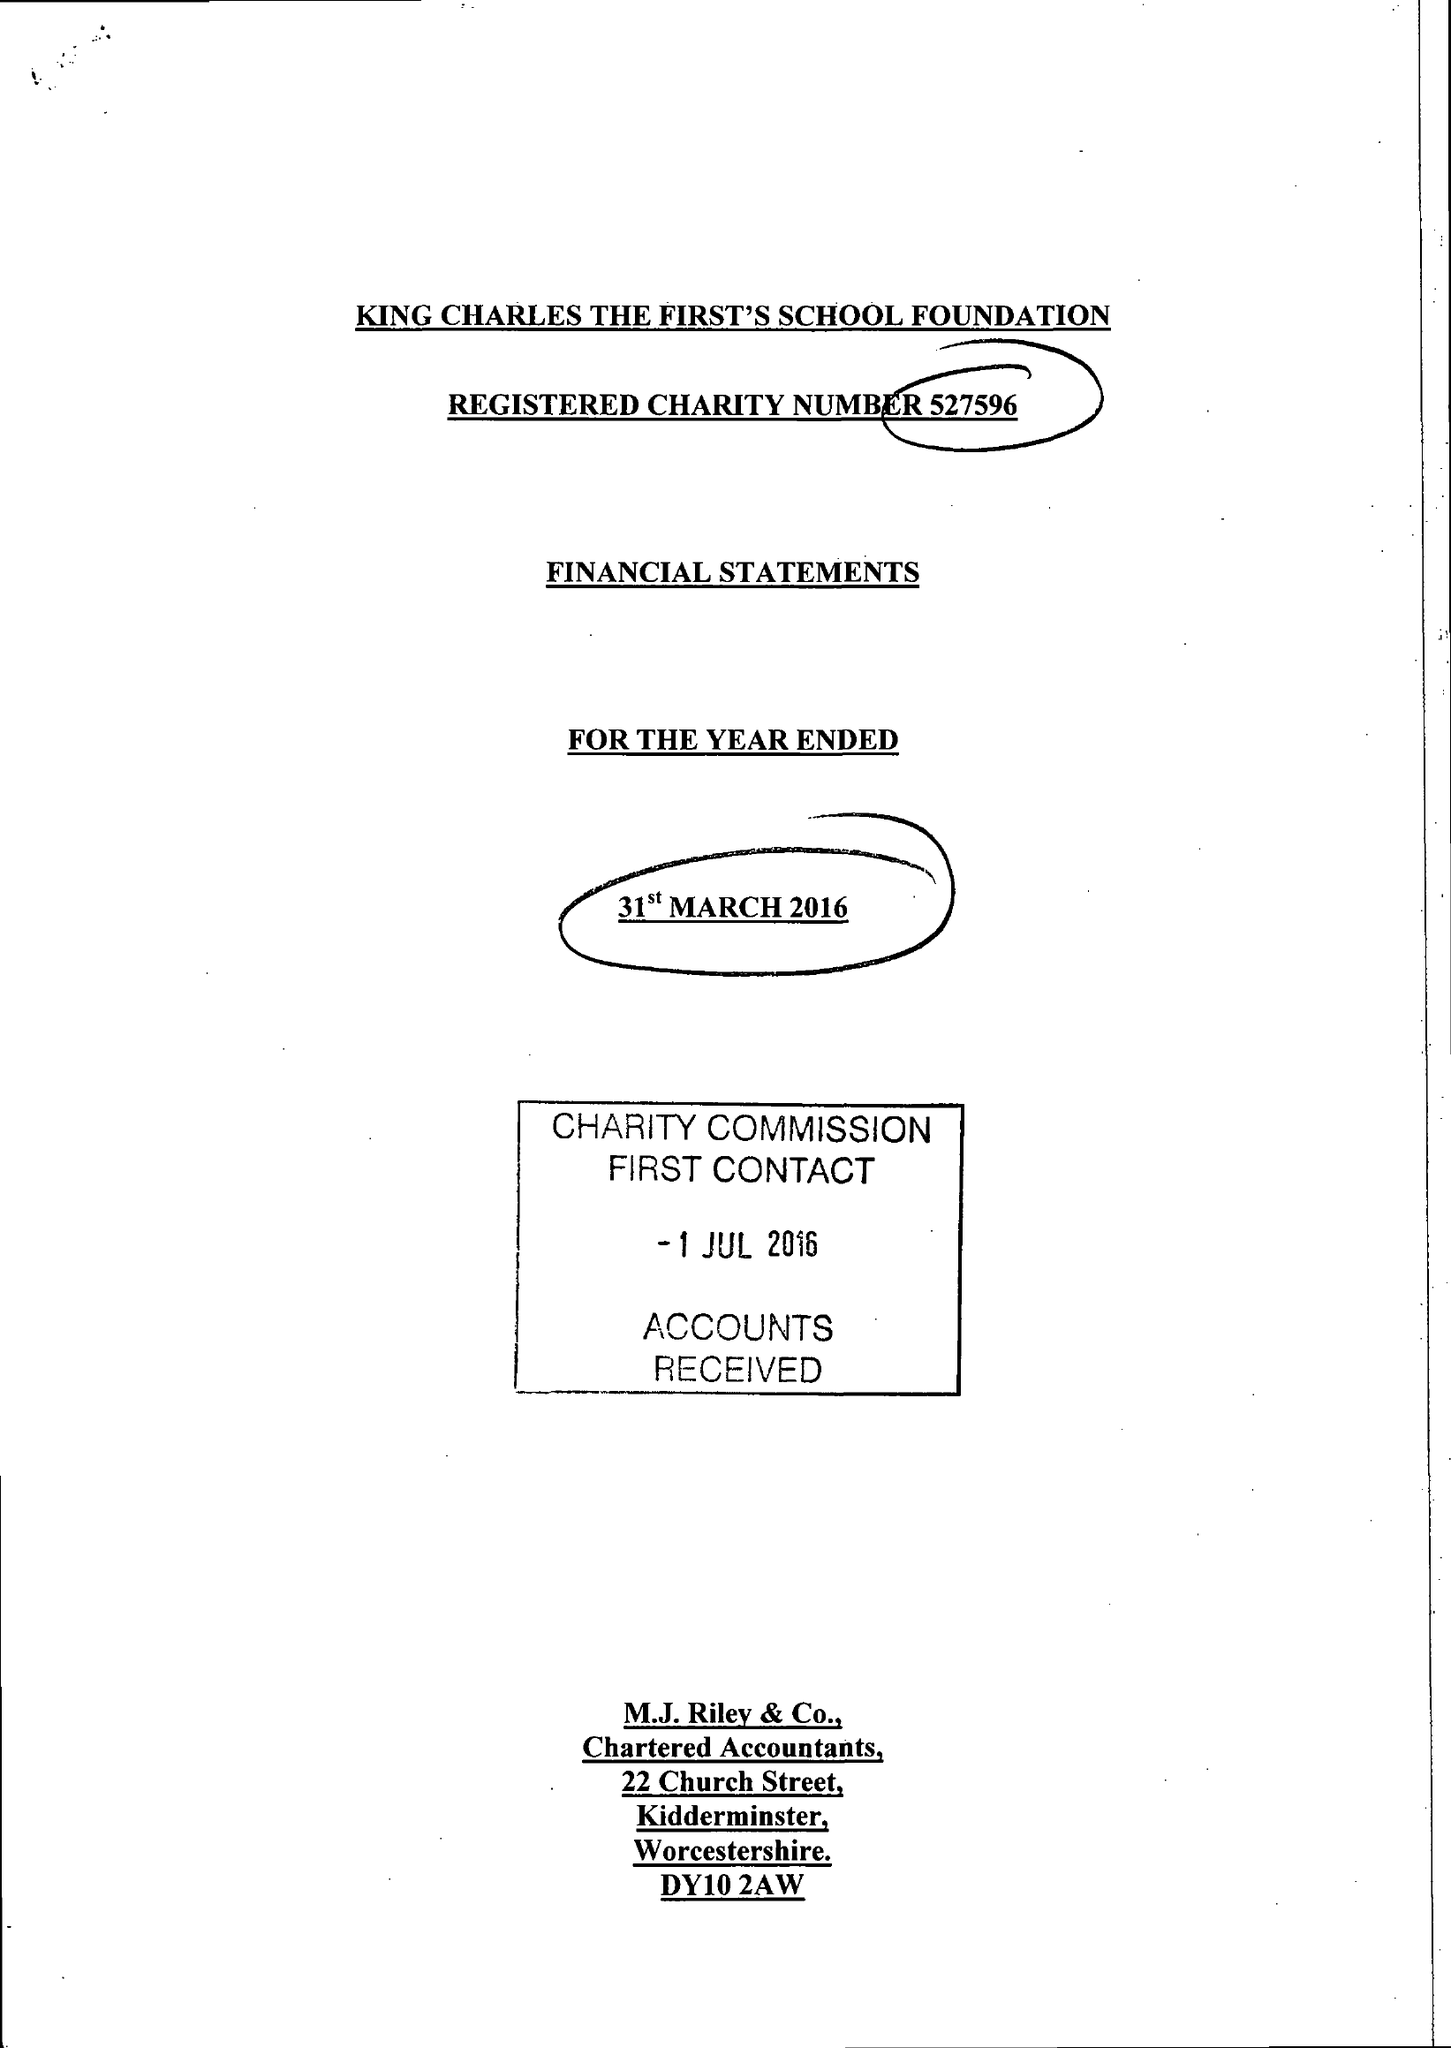What is the value for the address__postcode?
Answer the question using a single word or phrase. DY13 9JF 